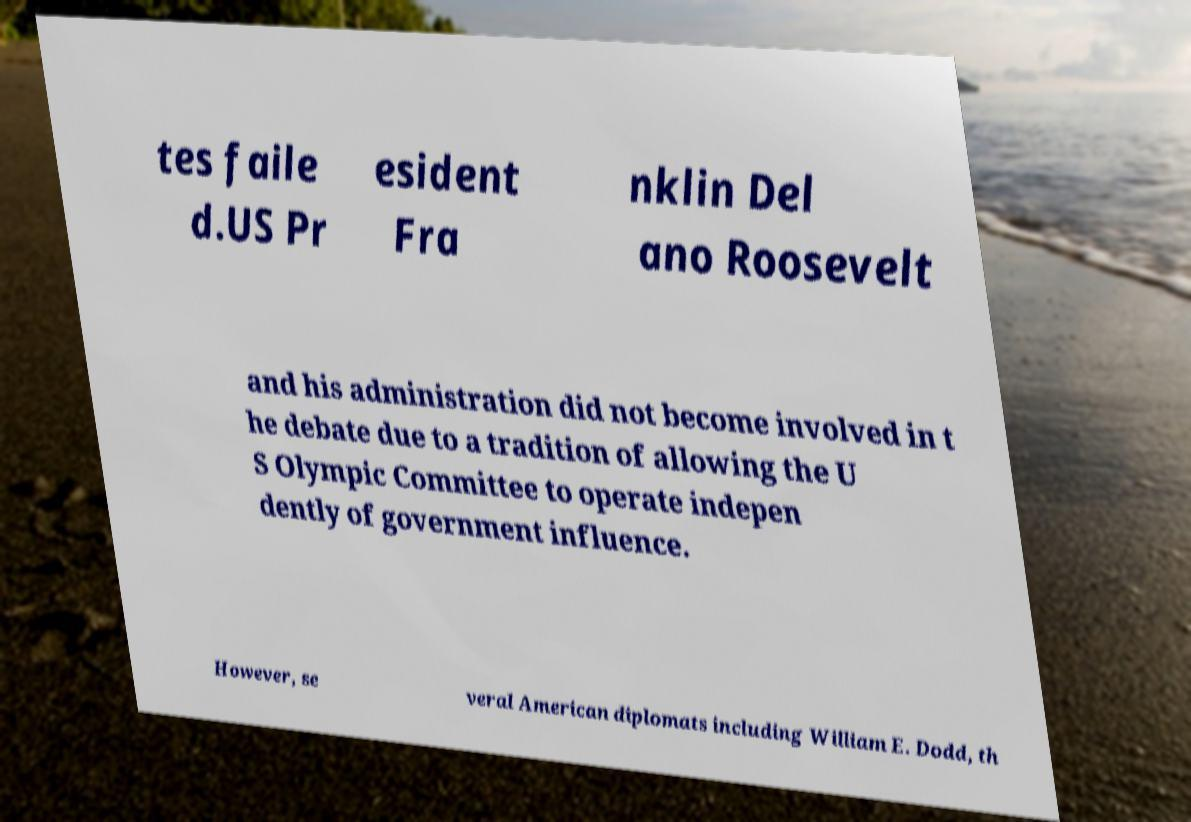Can you accurately transcribe the text from the provided image for me? tes faile d.US Pr esident Fra nklin Del ano Roosevelt and his administration did not become involved in t he debate due to a tradition of allowing the U S Olympic Committee to operate indepen dently of government influence. However, se veral American diplomats including William E. Dodd, th 